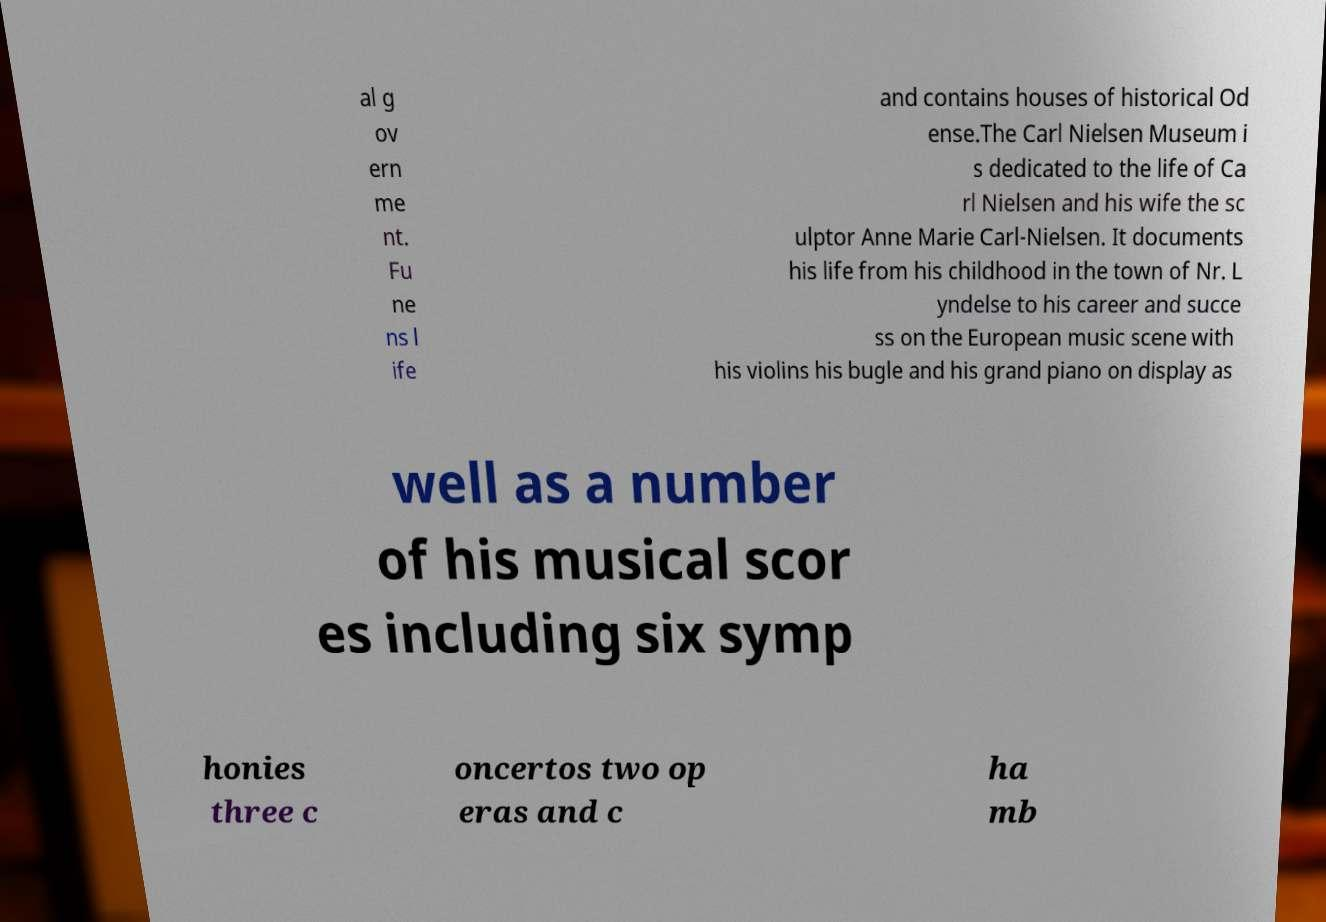Can you read and provide the text displayed in the image?This photo seems to have some interesting text. Can you extract and type it out for me? al g ov ern me nt. Fu ne ns l ife and contains houses of historical Od ense.The Carl Nielsen Museum i s dedicated to the life of Ca rl Nielsen and his wife the sc ulptor Anne Marie Carl-Nielsen. It documents his life from his childhood in the town of Nr. L yndelse to his career and succe ss on the European music scene with his violins his bugle and his grand piano on display as well as a number of his musical scor es including six symp honies three c oncertos two op eras and c ha mb 